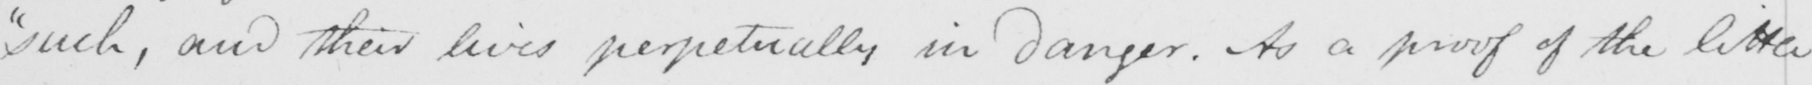Please transcribe the handwritten text in this image. "such, and their lives perpetually in danger. As a proof of the little 